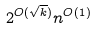Convert formula to latex. <formula><loc_0><loc_0><loc_500><loc_500>2 ^ { O ( \sqrt { k } ) } n ^ { O ( 1 ) }</formula> 